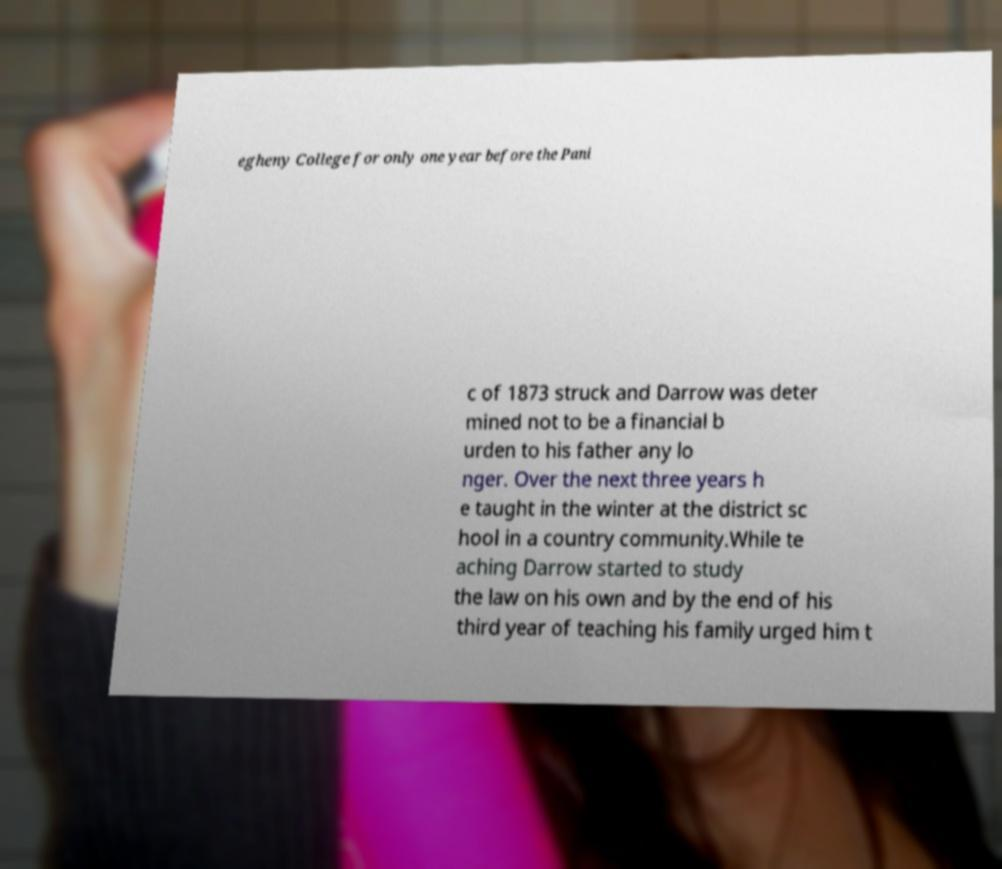Could you extract and type out the text from this image? egheny College for only one year before the Pani c of 1873 struck and Darrow was deter mined not to be a financial b urden to his father any lo nger. Over the next three years h e taught in the winter at the district sc hool in a country community.While te aching Darrow started to study the law on his own and by the end of his third year of teaching his family urged him t 